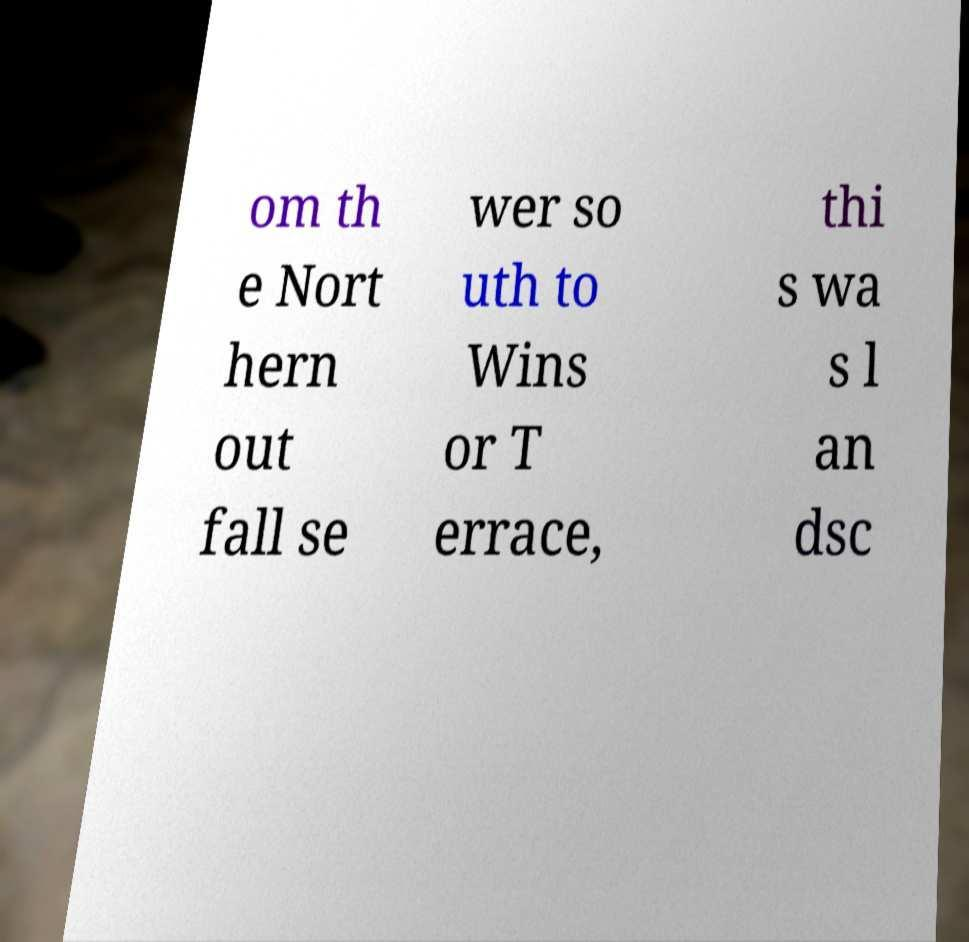Could you extract and type out the text from this image? om th e Nort hern out fall se wer so uth to Wins or T errace, thi s wa s l an dsc 